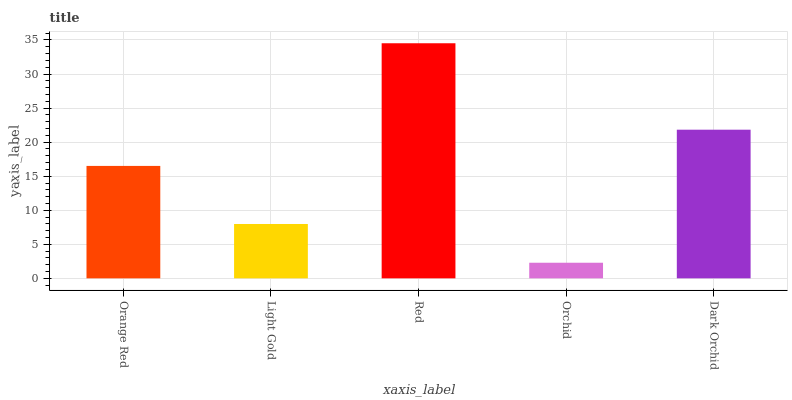Is Orchid the minimum?
Answer yes or no. Yes. Is Red the maximum?
Answer yes or no. Yes. Is Light Gold the minimum?
Answer yes or no. No. Is Light Gold the maximum?
Answer yes or no. No. Is Orange Red greater than Light Gold?
Answer yes or no. Yes. Is Light Gold less than Orange Red?
Answer yes or no. Yes. Is Light Gold greater than Orange Red?
Answer yes or no. No. Is Orange Red less than Light Gold?
Answer yes or no. No. Is Orange Red the high median?
Answer yes or no. Yes. Is Orange Red the low median?
Answer yes or no. Yes. Is Red the high median?
Answer yes or no. No. Is Light Gold the low median?
Answer yes or no. No. 